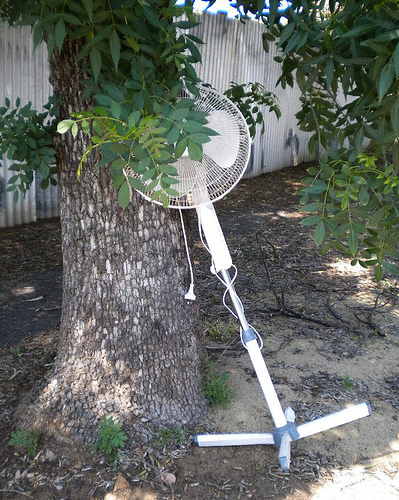<image>
Can you confirm if the tree is in front of the fan? No. The tree is not in front of the fan. The spatial positioning shows a different relationship between these objects. 